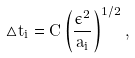Convert formula to latex. <formula><loc_0><loc_0><loc_500><loc_500>\triangle t _ { i } = C \left ( \frac { \epsilon ^ { 2 } } { a _ { i } } \right ) ^ { 1 / 2 } ,</formula> 